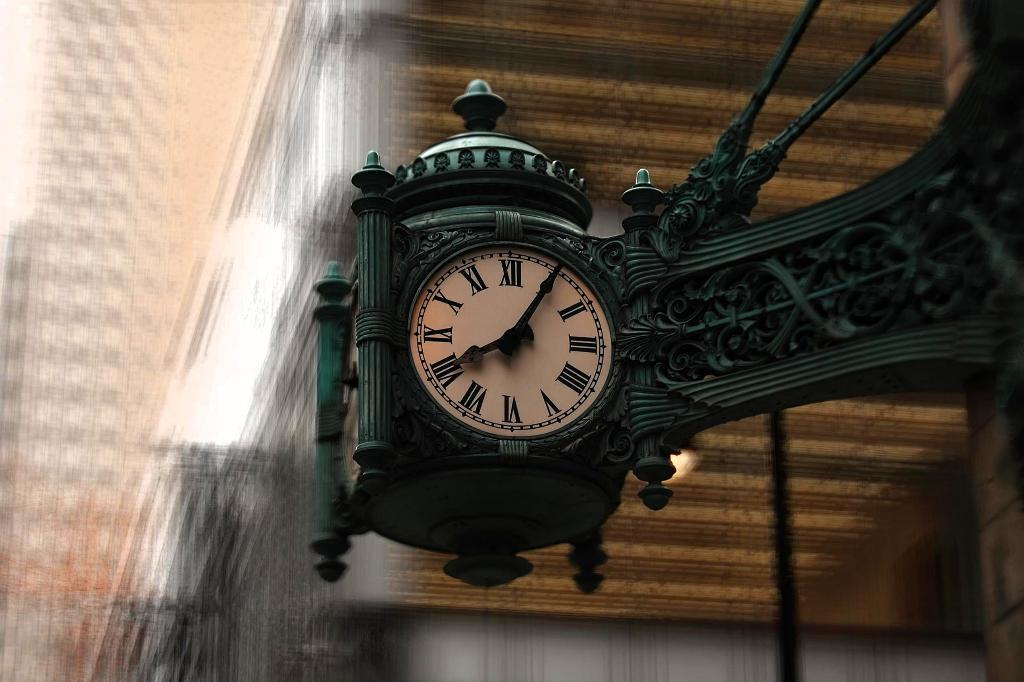Provide a one-sentence caption for the provided image. A street hanging green clock shows the time as 08:05. 